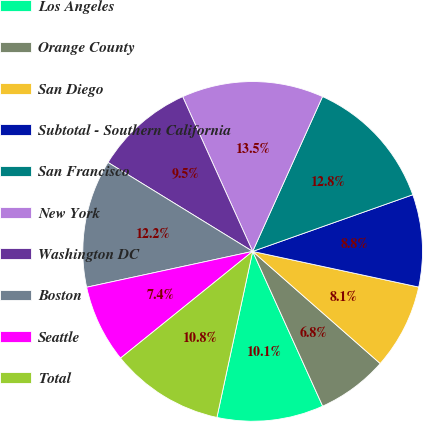<chart> <loc_0><loc_0><loc_500><loc_500><pie_chart><fcel>Los Angeles<fcel>Orange County<fcel>San Diego<fcel>Subtotal - Southern California<fcel>San Francisco<fcel>New York<fcel>Washington DC<fcel>Boston<fcel>Seattle<fcel>Total<nl><fcel>10.14%<fcel>6.76%<fcel>8.11%<fcel>8.78%<fcel>12.84%<fcel>13.51%<fcel>9.46%<fcel>12.16%<fcel>7.43%<fcel>10.81%<nl></chart> 